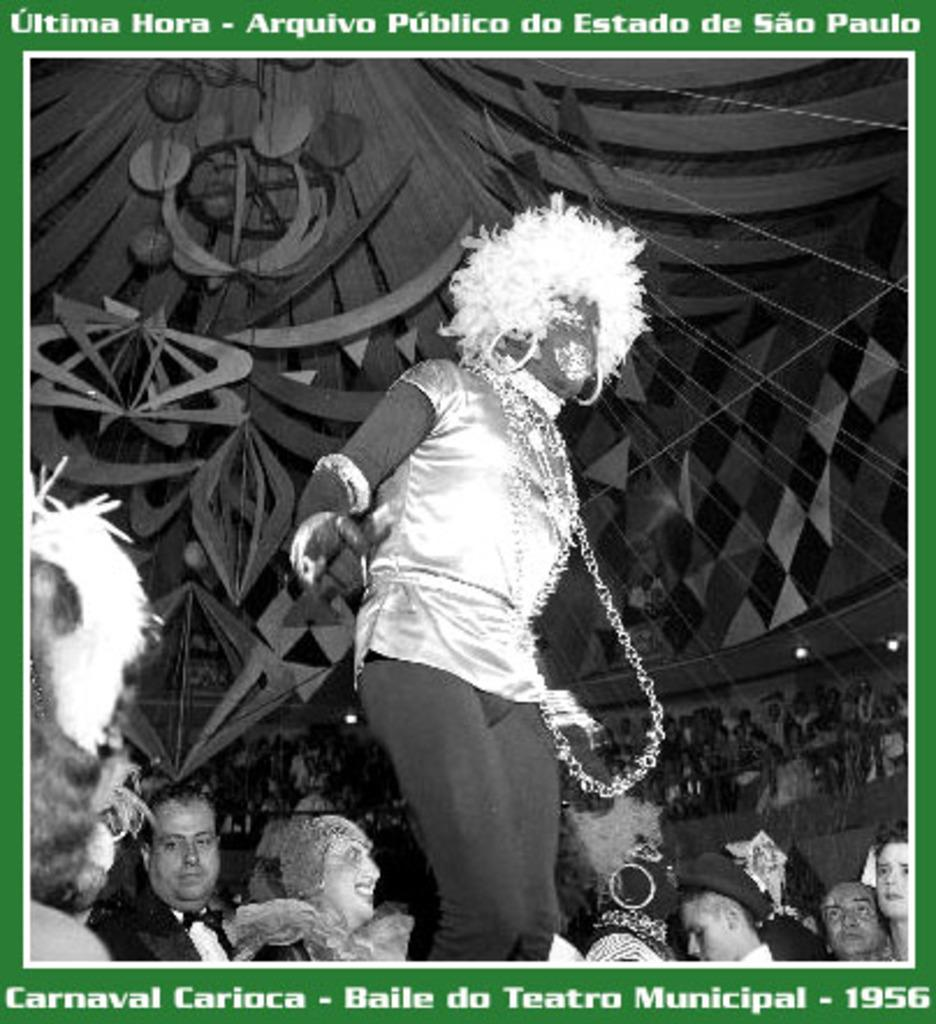What is the perspective of the image? The image was taken from inside. What can be seen on the floor in the image? People are standing on the floor in the image. What is located on the roof in the image? There is an object on top of the roof in the image. What type of bottle can be seen on the book in the image? There is no bottle or book present in the image. What activity are the people engaged in while standing on the floor in the image? The provided facts do not mention any specific activity that the people are engaged in; they are simply standing on the floor. 